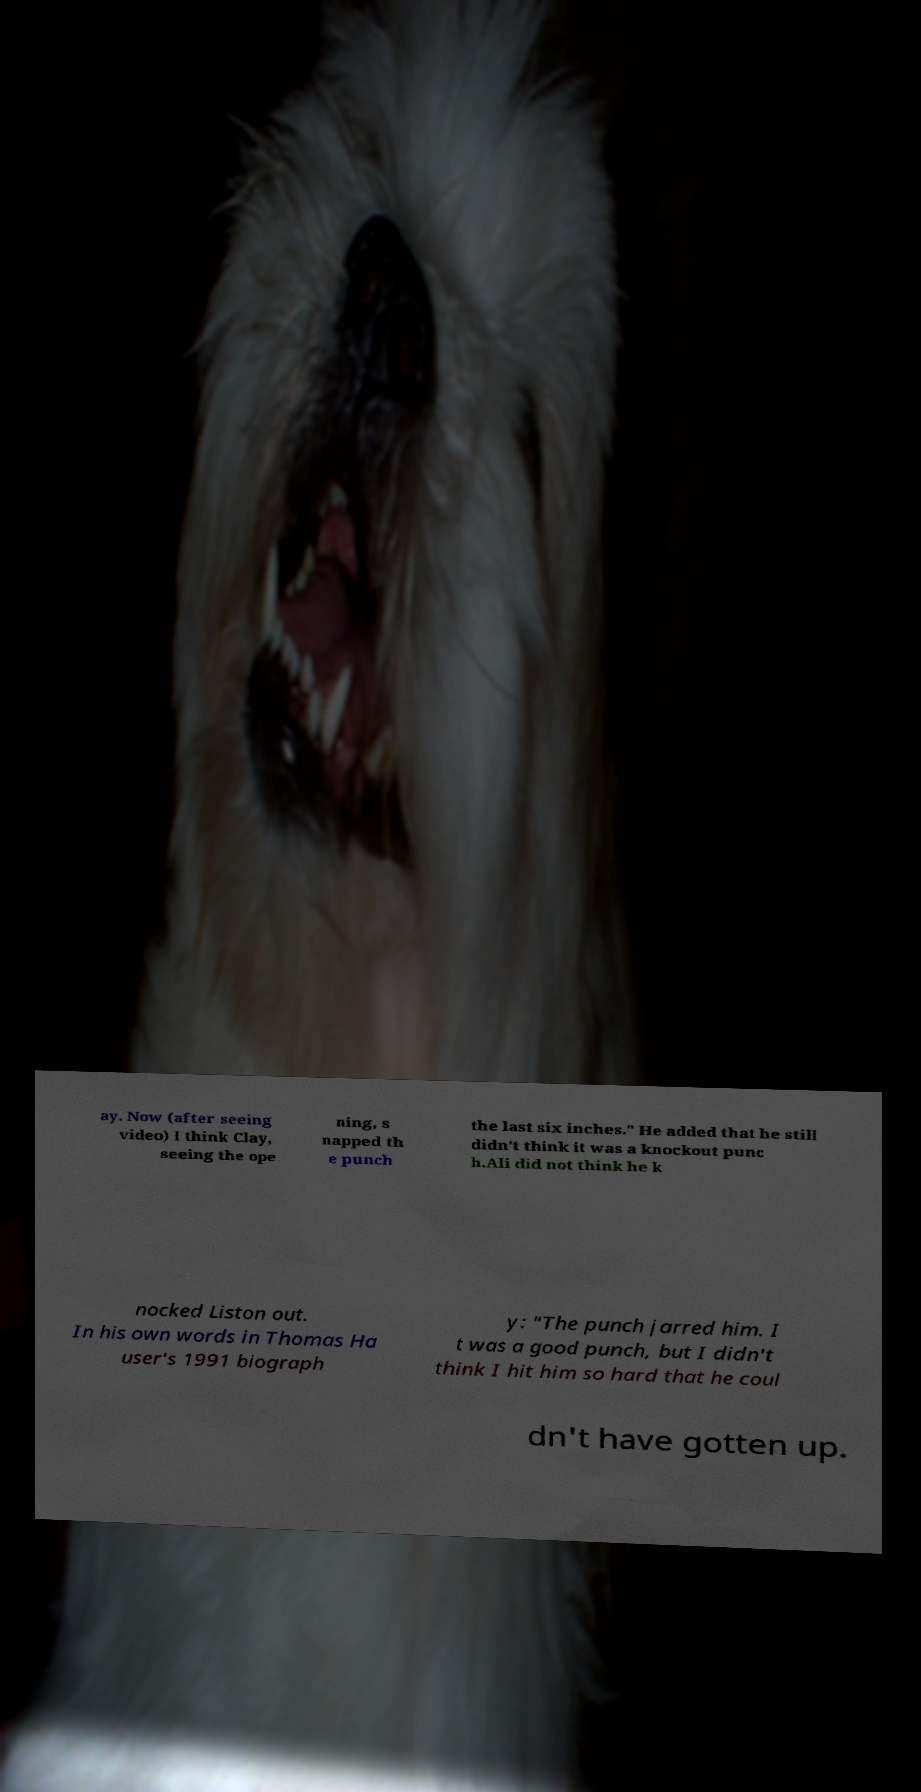Can you read and provide the text displayed in the image?This photo seems to have some interesting text. Can you extract and type it out for me? ay. Now (after seeing video) I think Clay, seeing the ope ning, s napped th e punch the last six inches." He added that he still didn't think it was a knockout punc h.Ali did not think he k nocked Liston out. In his own words in Thomas Ha user's 1991 biograph y: "The punch jarred him. I t was a good punch, but I didn't think I hit him so hard that he coul dn't have gotten up. 